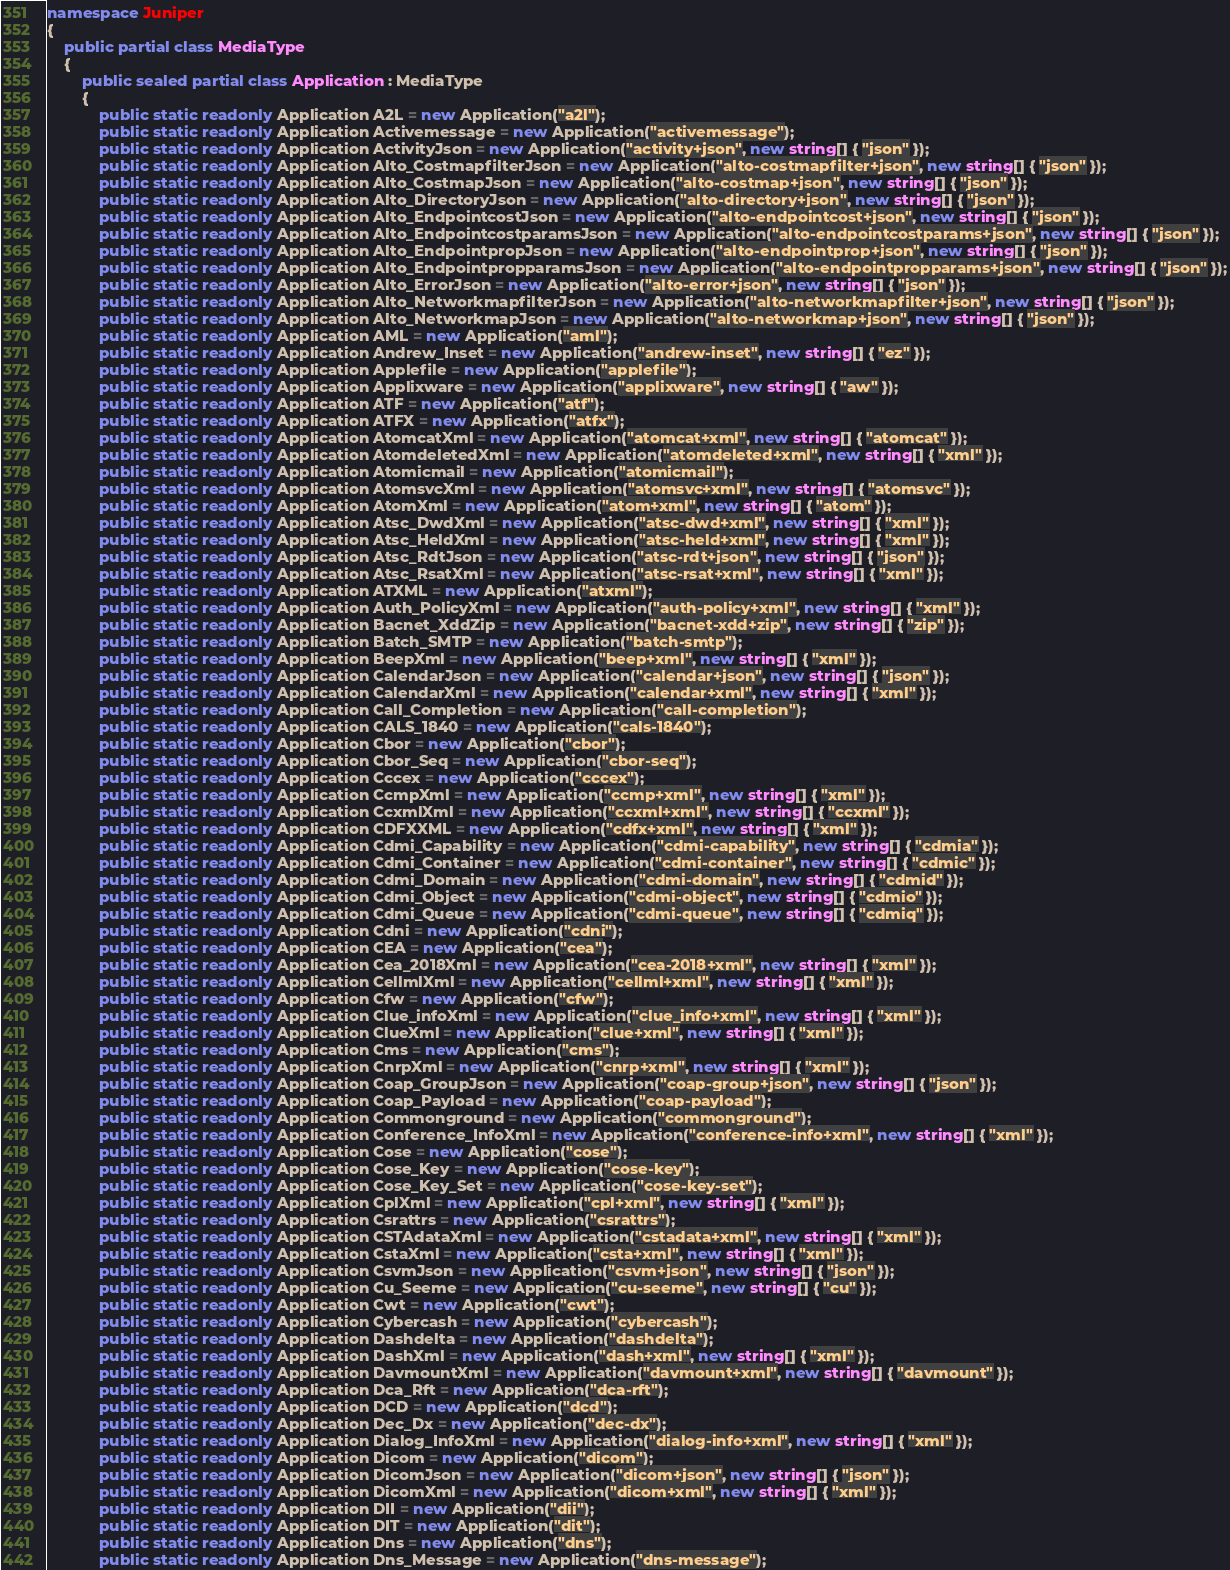Convert code to text. <code><loc_0><loc_0><loc_500><loc_500><_C#_>namespace Juniper
{
    public partial class MediaType
    {
        public sealed partial class Application : MediaType
        {
            public static readonly Application A2L = new Application("a2l");
            public static readonly Application Activemessage = new Application("activemessage");
            public static readonly Application ActivityJson = new Application("activity+json", new string[] { "json" });
            public static readonly Application Alto_CostmapfilterJson = new Application("alto-costmapfilter+json", new string[] { "json" });
            public static readonly Application Alto_CostmapJson = new Application("alto-costmap+json", new string[] { "json" });
            public static readonly Application Alto_DirectoryJson = new Application("alto-directory+json", new string[] { "json" });
            public static readonly Application Alto_EndpointcostJson = new Application("alto-endpointcost+json", new string[] { "json" });
            public static readonly Application Alto_EndpointcostparamsJson = new Application("alto-endpointcostparams+json", new string[] { "json" });
            public static readonly Application Alto_EndpointpropJson = new Application("alto-endpointprop+json", new string[] { "json" });
            public static readonly Application Alto_EndpointpropparamsJson = new Application("alto-endpointpropparams+json", new string[] { "json" });
            public static readonly Application Alto_ErrorJson = new Application("alto-error+json", new string[] { "json" });
            public static readonly Application Alto_NetworkmapfilterJson = new Application("alto-networkmapfilter+json", new string[] { "json" });
            public static readonly Application Alto_NetworkmapJson = new Application("alto-networkmap+json", new string[] { "json" });
            public static readonly Application AML = new Application("aml");
            public static readonly Application Andrew_Inset = new Application("andrew-inset", new string[] { "ez" });
            public static readonly Application Applefile = new Application("applefile");
            public static readonly Application Applixware = new Application("applixware", new string[] { "aw" });
            public static readonly Application ATF = new Application("atf");
            public static readonly Application ATFX = new Application("atfx");
            public static readonly Application AtomcatXml = new Application("atomcat+xml", new string[] { "atomcat" });
            public static readonly Application AtomdeletedXml = new Application("atomdeleted+xml", new string[] { "xml" });
            public static readonly Application Atomicmail = new Application("atomicmail");
            public static readonly Application AtomsvcXml = new Application("atomsvc+xml", new string[] { "atomsvc" });
            public static readonly Application AtomXml = new Application("atom+xml", new string[] { "atom" });
            public static readonly Application Atsc_DwdXml = new Application("atsc-dwd+xml", new string[] { "xml" });
            public static readonly Application Atsc_HeldXml = new Application("atsc-held+xml", new string[] { "xml" });
            public static readonly Application Atsc_RdtJson = new Application("atsc-rdt+json", new string[] { "json" });
            public static readonly Application Atsc_RsatXml = new Application("atsc-rsat+xml", new string[] { "xml" });
            public static readonly Application ATXML = new Application("atxml");
            public static readonly Application Auth_PolicyXml = new Application("auth-policy+xml", new string[] { "xml" });
            public static readonly Application Bacnet_XddZip = new Application("bacnet-xdd+zip", new string[] { "zip" });
            public static readonly Application Batch_SMTP = new Application("batch-smtp");
            public static readonly Application BeepXml = new Application("beep+xml", new string[] { "xml" });
            public static readonly Application CalendarJson = new Application("calendar+json", new string[] { "json" });
            public static readonly Application CalendarXml = new Application("calendar+xml", new string[] { "xml" });
            public static readonly Application Call_Completion = new Application("call-completion");
            public static readonly Application CALS_1840 = new Application("cals-1840");
            public static readonly Application Cbor = new Application("cbor");
            public static readonly Application Cbor_Seq = new Application("cbor-seq");
            public static readonly Application Cccex = new Application("cccex");
            public static readonly Application CcmpXml = new Application("ccmp+xml", new string[] { "xml" });
            public static readonly Application CcxmlXml = new Application("ccxml+xml", new string[] { "ccxml" });
            public static readonly Application CDFXXML = new Application("cdfx+xml", new string[] { "xml" });
            public static readonly Application Cdmi_Capability = new Application("cdmi-capability", new string[] { "cdmia" });
            public static readonly Application Cdmi_Container = new Application("cdmi-container", new string[] { "cdmic" });
            public static readonly Application Cdmi_Domain = new Application("cdmi-domain", new string[] { "cdmid" });
            public static readonly Application Cdmi_Object = new Application("cdmi-object", new string[] { "cdmio" });
            public static readonly Application Cdmi_Queue = new Application("cdmi-queue", new string[] { "cdmiq" });
            public static readonly Application Cdni = new Application("cdni");
            public static readonly Application CEA = new Application("cea");
            public static readonly Application Cea_2018Xml = new Application("cea-2018+xml", new string[] { "xml" });
            public static readonly Application CellmlXml = new Application("cellml+xml", new string[] { "xml" });
            public static readonly Application Cfw = new Application("cfw");
            public static readonly Application Clue_infoXml = new Application("clue_info+xml", new string[] { "xml" });
            public static readonly Application ClueXml = new Application("clue+xml", new string[] { "xml" });
            public static readonly Application Cms = new Application("cms");
            public static readonly Application CnrpXml = new Application("cnrp+xml", new string[] { "xml" });
            public static readonly Application Coap_GroupJson = new Application("coap-group+json", new string[] { "json" });
            public static readonly Application Coap_Payload = new Application("coap-payload");
            public static readonly Application Commonground = new Application("commonground");
            public static readonly Application Conference_InfoXml = new Application("conference-info+xml", new string[] { "xml" });
            public static readonly Application Cose = new Application("cose");
            public static readonly Application Cose_Key = new Application("cose-key");
            public static readonly Application Cose_Key_Set = new Application("cose-key-set");
            public static readonly Application CplXml = new Application("cpl+xml", new string[] { "xml" });
            public static readonly Application Csrattrs = new Application("csrattrs");
            public static readonly Application CSTAdataXml = new Application("cstadata+xml", new string[] { "xml" });
            public static readonly Application CstaXml = new Application("csta+xml", new string[] { "xml" });
            public static readonly Application CsvmJson = new Application("csvm+json", new string[] { "json" });
            public static readonly Application Cu_Seeme = new Application("cu-seeme", new string[] { "cu" });
            public static readonly Application Cwt = new Application("cwt");
            public static readonly Application Cybercash = new Application("cybercash");
            public static readonly Application Dashdelta = new Application("dashdelta");
            public static readonly Application DashXml = new Application("dash+xml", new string[] { "xml" });
            public static readonly Application DavmountXml = new Application("davmount+xml", new string[] { "davmount" });
            public static readonly Application Dca_Rft = new Application("dca-rft");
            public static readonly Application DCD = new Application("dcd");
            public static readonly Application Dec_Dx = new Application("dec-dx");
            public static readonly Application Dialog_InfoXml = new Application("dialog-info+xml", new string[] { "xml" });
            public static readonly Application Dicom = new Application("dicom");
            public static readonly Application DicomJson = new Application("dicom+json", new string[] { "json" });
            public static readonly Application DicomXml = new Application("dicom+xml", new string[] { "xml" });
            public static readonly Application DII = new Application("dii");
            public static readonly Application DIT = new Application("dit");
            public static readonly Application Dns = new Application("dns");
            public static readonly Application Dns_Message = new Application("dns-message");</code> 